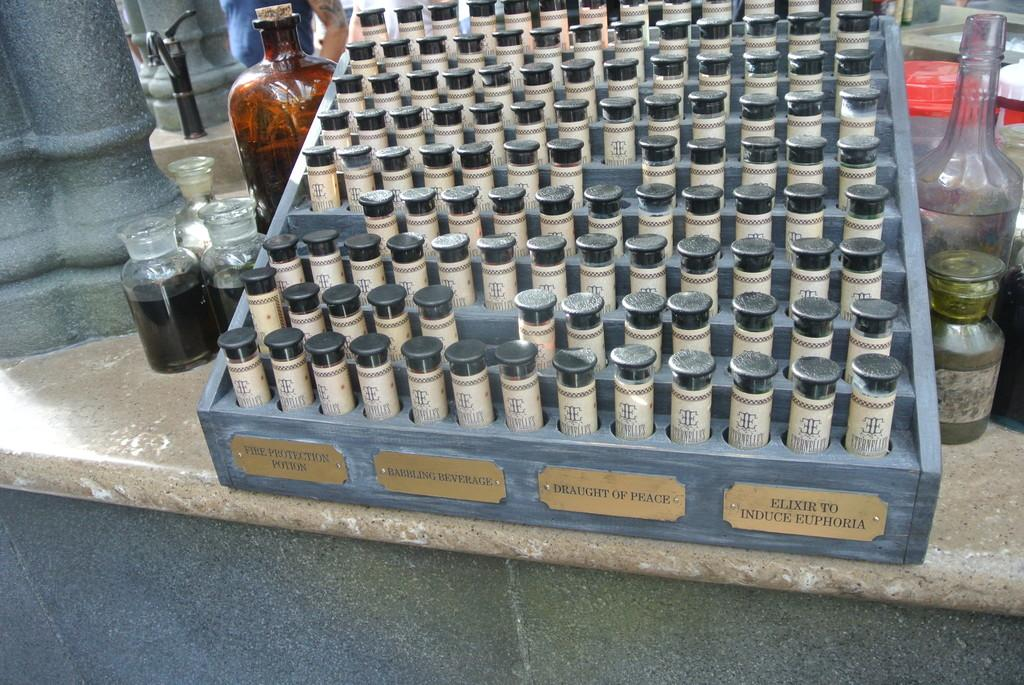Provide a one-sentence caption for the provided image. A collection of vials of potions and elixirs in rows. 